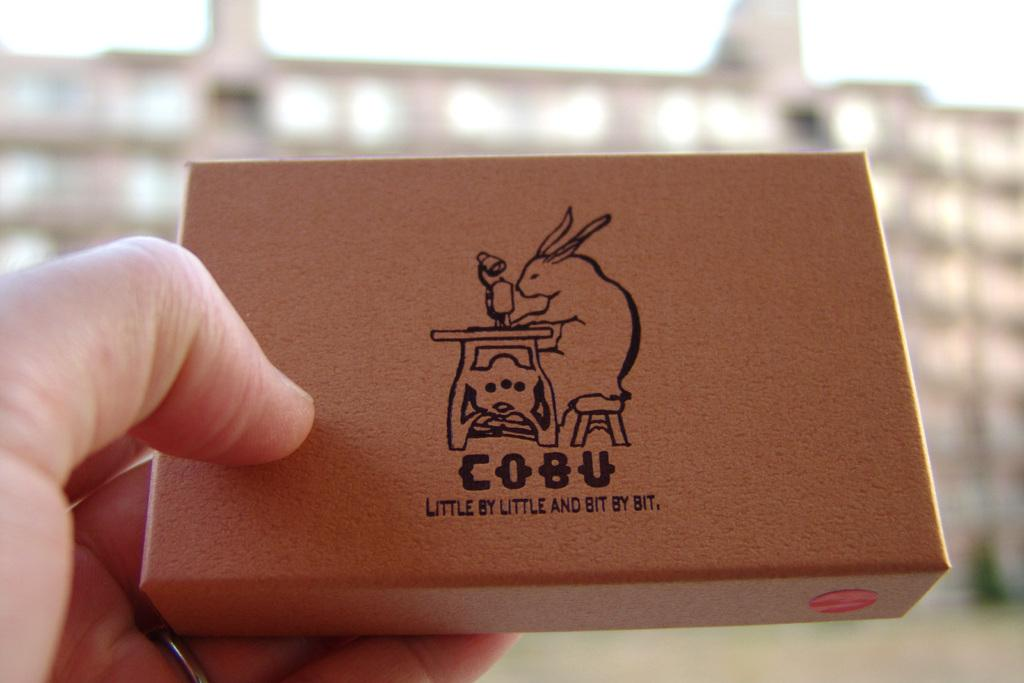<image>
Create a compact narrative representing the image presented. A box with a rabbit and brand name known as "Cobu". 